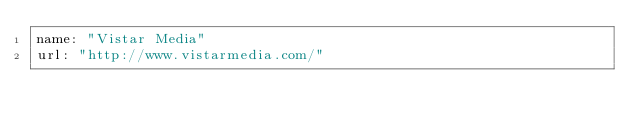<code> <loc_0><loc_0><loc_500><loc_500><_YAML_>name: "Vistar Media"
url: "http://www.vistarmedia.com/"
</code> 